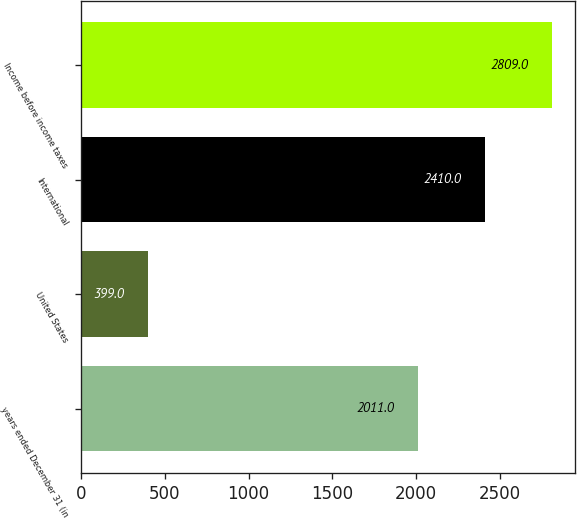Convert chart to OTSL. <chart><loc_0><loc_0><loc_500><loc_500><bar_chart><fcel>years ended December 31 (in<fcel>United States<fcel>International<fcel>Income before income taxes<nl><fcel>2011<fcel>399<fcel>2410<fcel>2809<nl></chart> 